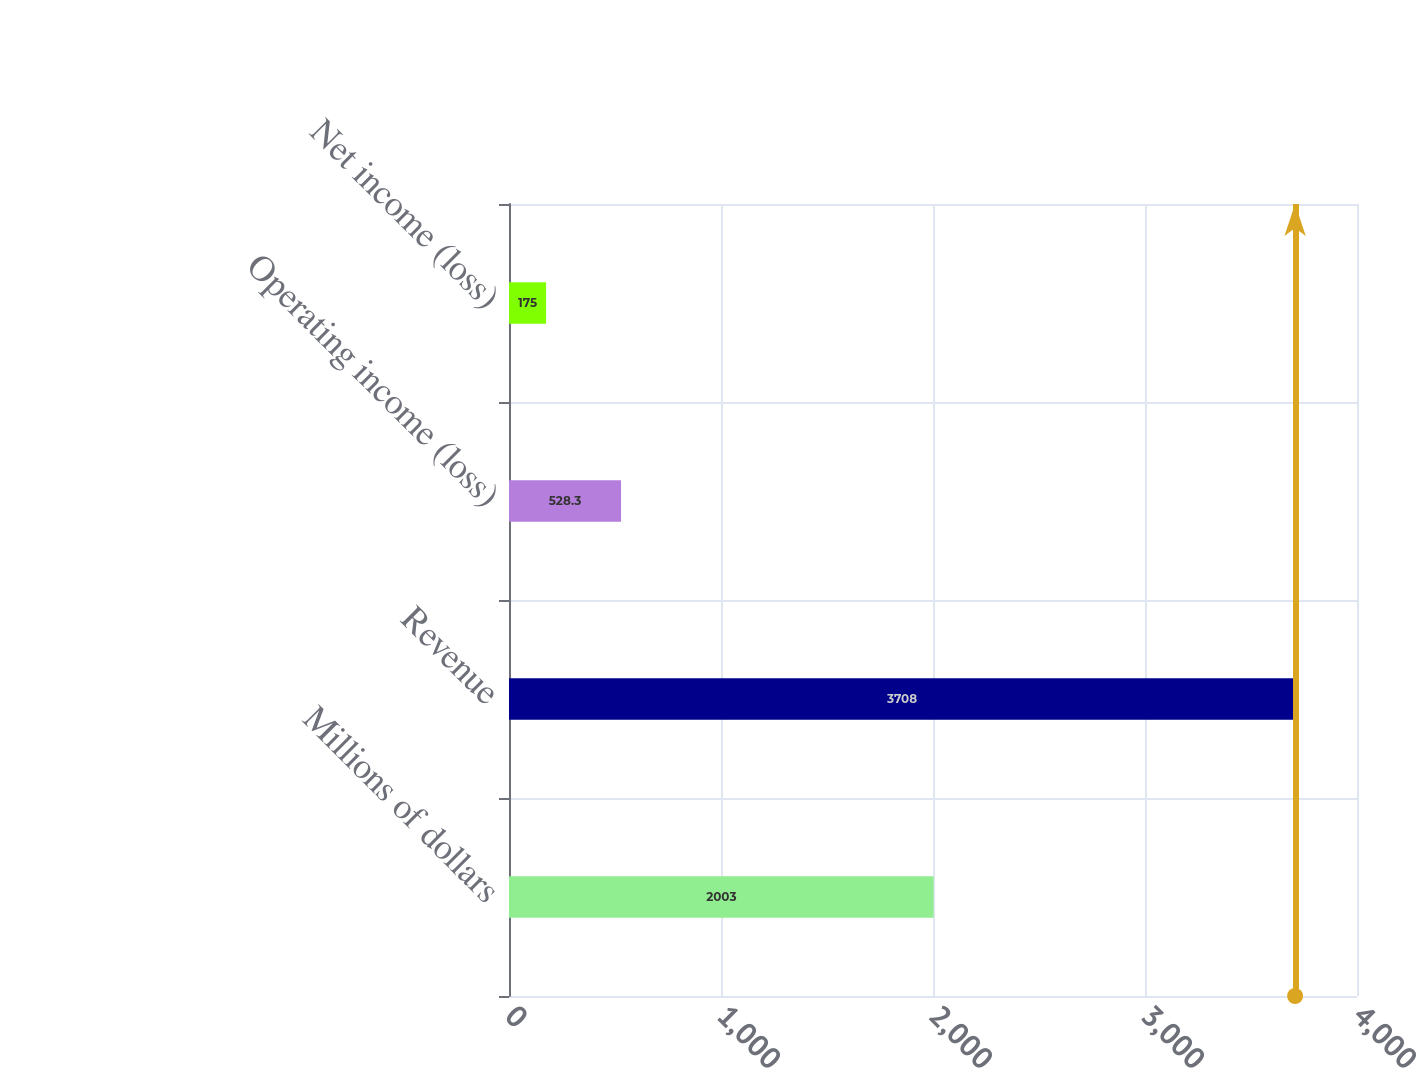Convert chart. <chart><loc_0><loc_0><loc_500><loc_500><bar_chart><fcel>Millions of dollars<fcel>Revenue<fcel>Operating income (loss)<fcel>Net income (loss)<nl><fcel>2003<fcel>3708<fcel>528.3<fcel>175<nl></chart> 